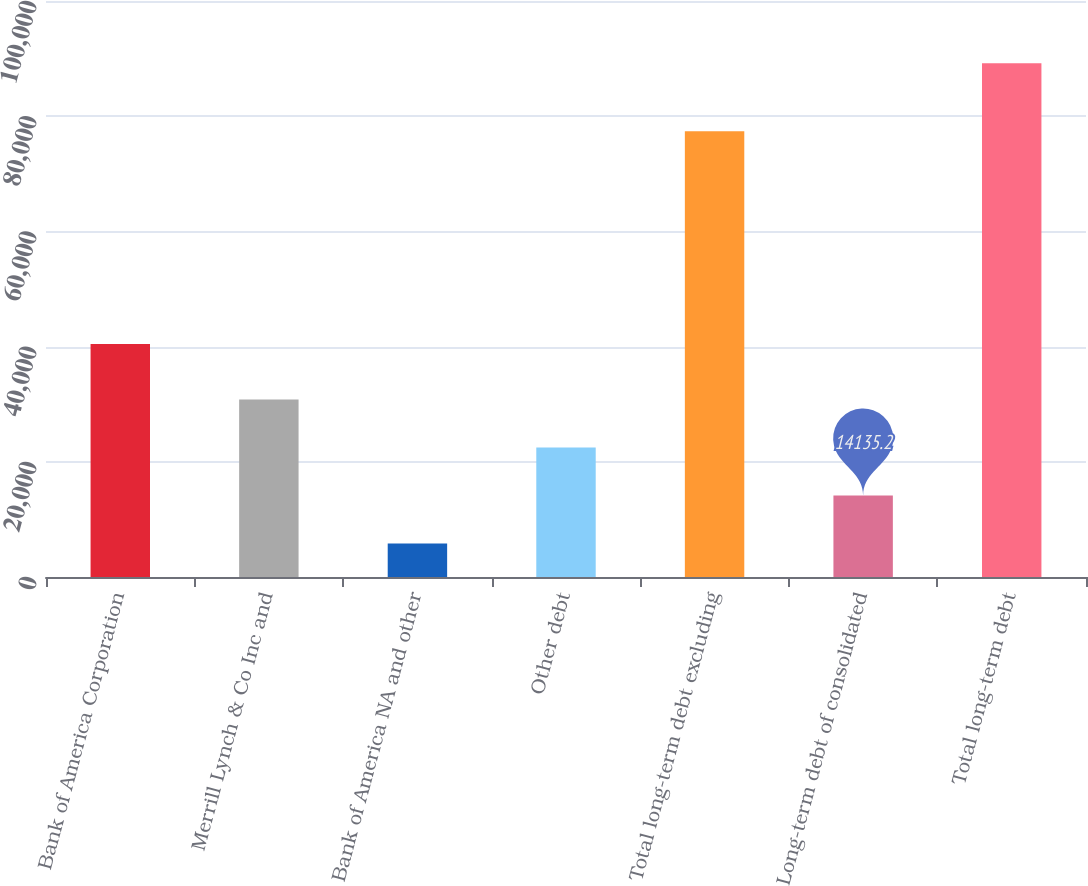<chart> <loc_0><loc_0><loc_500><loc_500><bar_chart><fcel>Bank of America Corporation<fcel>Merrill Lynch & Co Inc and<fcel>Bank of America NA and other<fcel>Other debt<fcel>Total long-term debt excluding<fcel>Long-term debt of consolidated<fcel>Total long-term debt<nl><fcel>40432<fcel>30813.6<fcel>5796<fcel>22474.4<fcel>77388<fcel>14135.2<fcel>89188<nl></chart> 